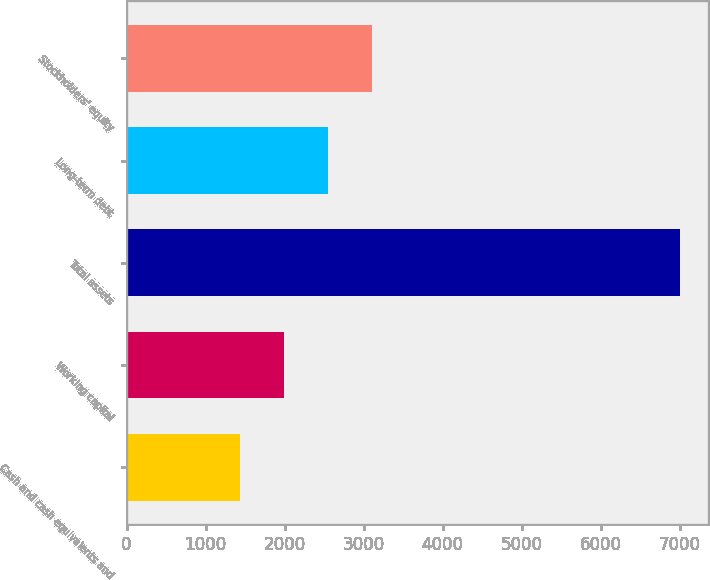Convert chart. <chart><loc_0><loc_0><loc_500><loc_500><bar_chart><fcel>Cash and cash equivalents and<fcel>Working capital<fcel>Total assets<fcel>Long-term debt<fcel>Stockholders' equity<nl><fcel>1429<fcel>1986.8<fcel>7007<fcel>2544.6<fcel>3102.4<nl></chart> 